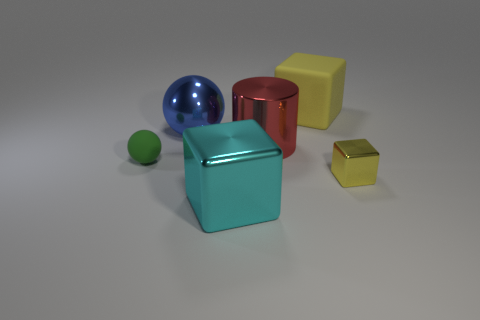What size is the other block that is the same color as the large rubber cube?
Ensure brevity in your answer.  Small. The rubber thing behind the large cylinder has what shape?
Offer a very short reply. Cube. Is the shape of the large metallic object in front of the small green rubber sphere the same as  the big rubber object?
Provide a short and direct response. Yes. What number of objects are either cubes that are behind the tiny yellow object or red objects?
Your answer should be very brief. 2. The large metal object that is the same shape as the tiny green thing is what color?
Give a very brief answer. Blue. Are there any other things that are the same color as the rubber block?
Provide a succinct answer. Yes. What size is the metallic cube that is on the left side of the large yellow block?
Provide a short and direct response. Large. There is a small shiny cube; does it have the same color as the rubber object to the right of the green object?
Provide a succinct answer. Yes. What number of other objects are the same material as the red cylinder?
Your response must be concise. 3. Are there more small red matte things than blue balls?
Provide a succinct answer. No. 